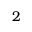<formula> <loc_0><loc_0><loc_500><loc_500>2</formula> 